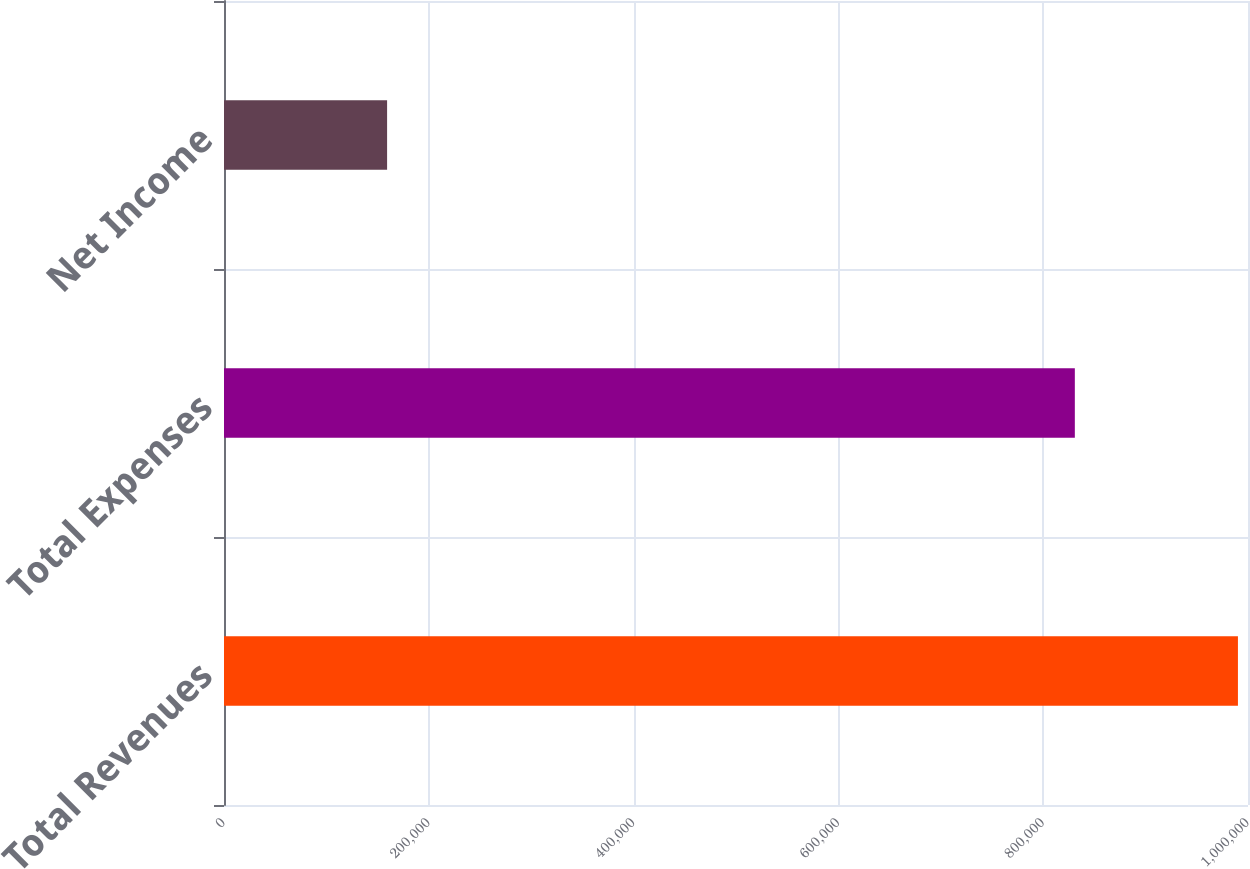Convert chart to OTSL. <chart><loc_0><loc_0><loc_500><loc_500><bar_chart><fcel>Total Revenues<fcel>Total Expenses<fcel>Net Income<nl><fcel>990172<fcel>830898<fcel>159274<nl></chart> 